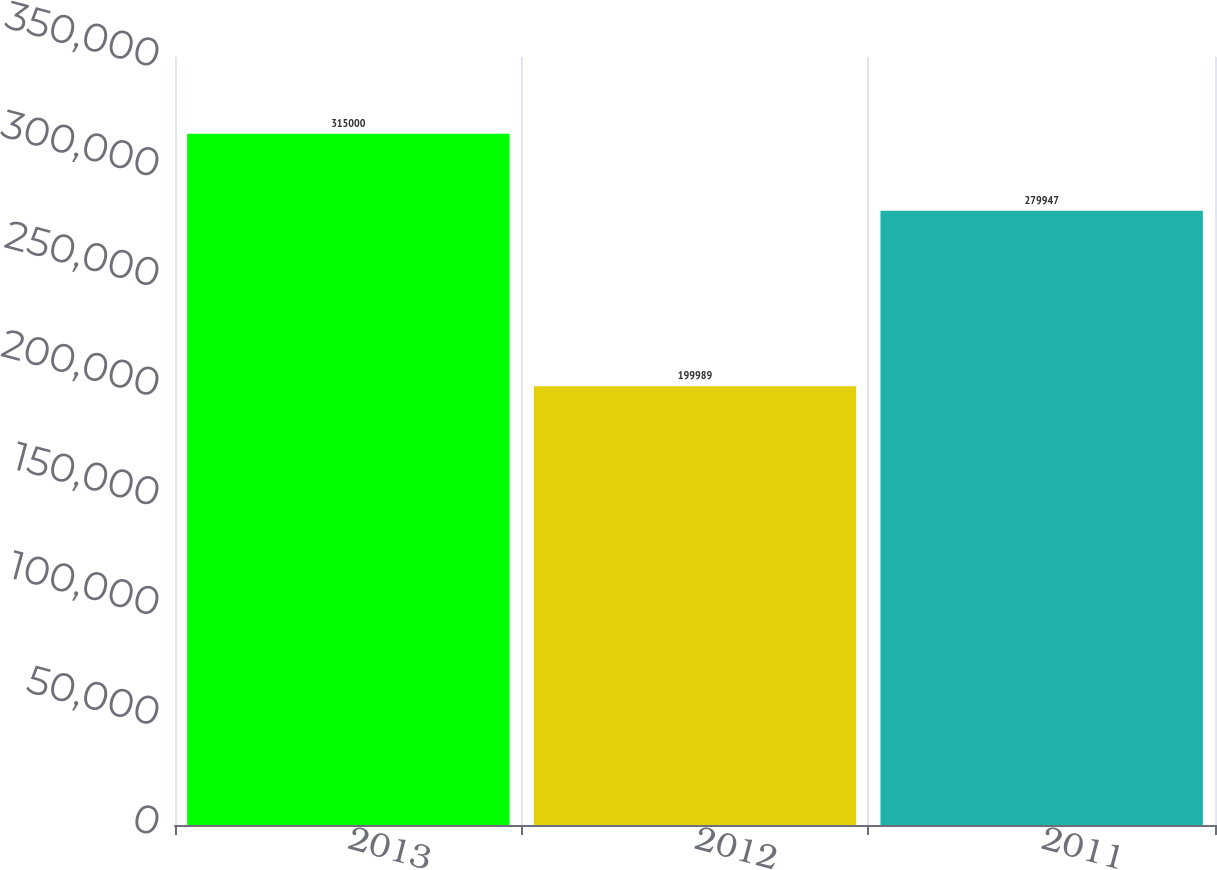<chart> <loc_0><loc_0><loc_500><loc_500><bar_chart><fcel>2013<fcel>2012<fcel>2011<nl><fcel>315000<fcel>199989<fcel>279947<nl></chart> 